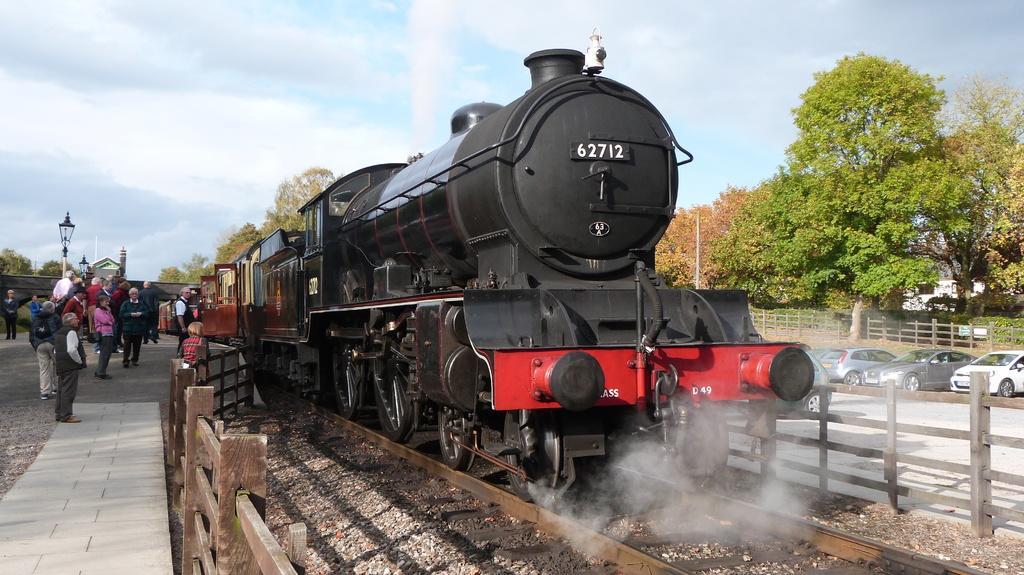How would you summarize this image in a sentence or two? In this image we can see a train on the railway track. Here we can see the wooden fence, a few people standing on the platform, we can see light poles, cars parked here, bridge, trees and the blue sky with clouds in the background. 